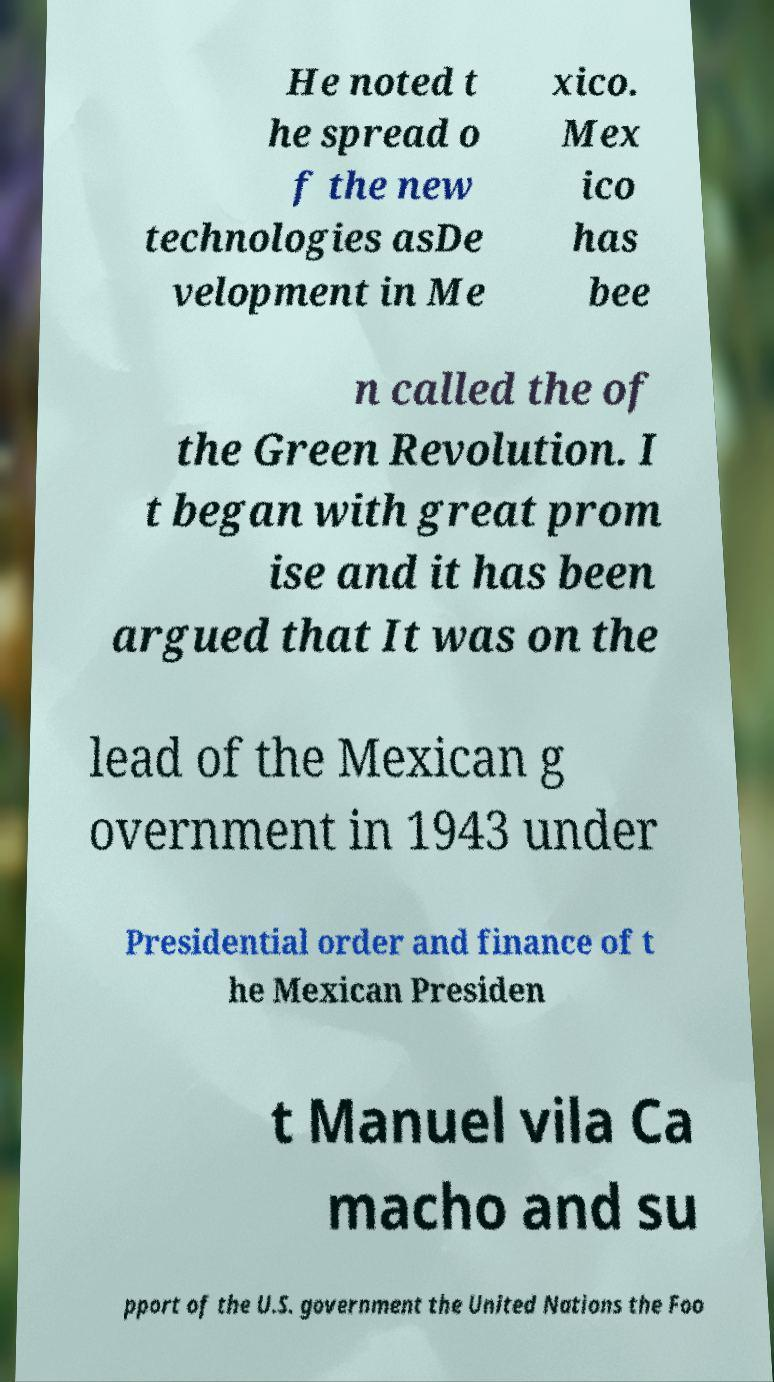I need the written content from this picture converted into text. Can you do that? He noted t he spread o f the new technologies asDe velopment in Me xico. Mex ico has bee n called the of the Green Revolution. I t began with great prom ise and it has been argued that It was on the lead of the Mexican g overnment in 1943 under Presidential order and finance of t he Mexican Presiden t Manuel vila Ca macho and su pport of the U.S. government the United Nations the Foo 